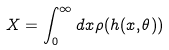<formula> <loc_0><loc_0><loc_500><loc_500>X = \int _ { 0 } ^ { \infty } d x \rho ( h ( x , \theta ) )</formula> 